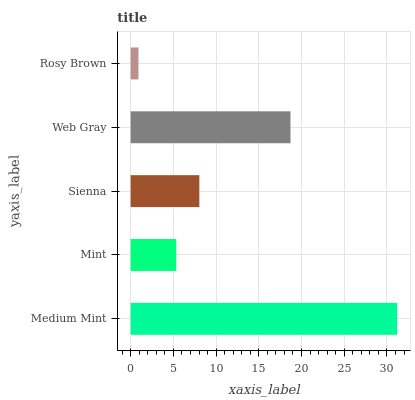Is Rosy Brown the minimum?
Answer yes or no. Yes. Is Medium Mint the maximum?
Answer yes or no. Yes. Is Mint the minimum?
Answer yes or no. No. Is Mint the maximum?
Answer yes or no. No. Is Medium Mint greater than Mint?
Answer yes or no. Yes. Is Mint less than Medium Mint?
Answer yes or no. Yes. Is Mint greater than Medium Mint?
Answer yes or no. No. Is Medium Mint less than Mint?
Answer yes or no. No. Is Sienna the high median?
Answer yes or no. Yes. Is Sienna the low median?
Answer yes or no. Yes. Is Mint the high median?
Answer yes or no. No. Is Rosy Brown the low median?
Answer yes or no. No. 